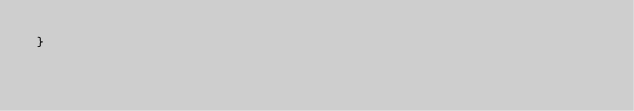<code> <loc_0><loc_0><loc_500><loc_500><_C++_>}
</code> 